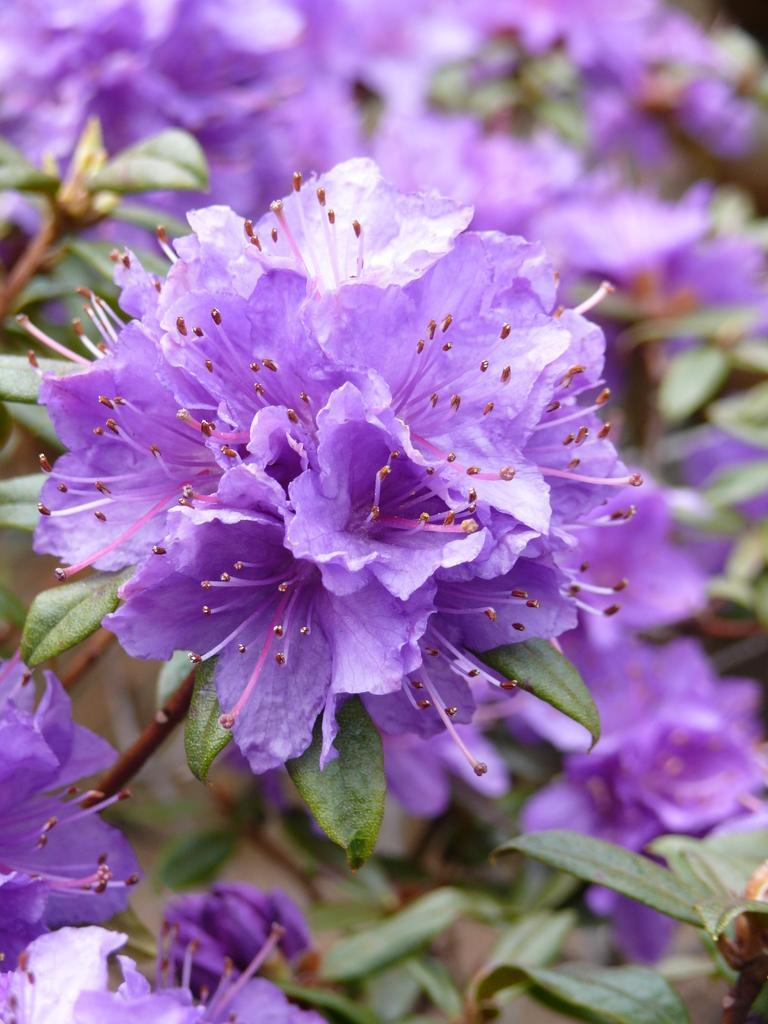What is the main subject in the center of the image? There is a flower in the center of the image. What can be seen in the background of the image? There are other flowers and leaves in the background of the image. What type of polish is being applied to the flowers in the image? There is no indication in the image that any polish is being applied to the flowers. 